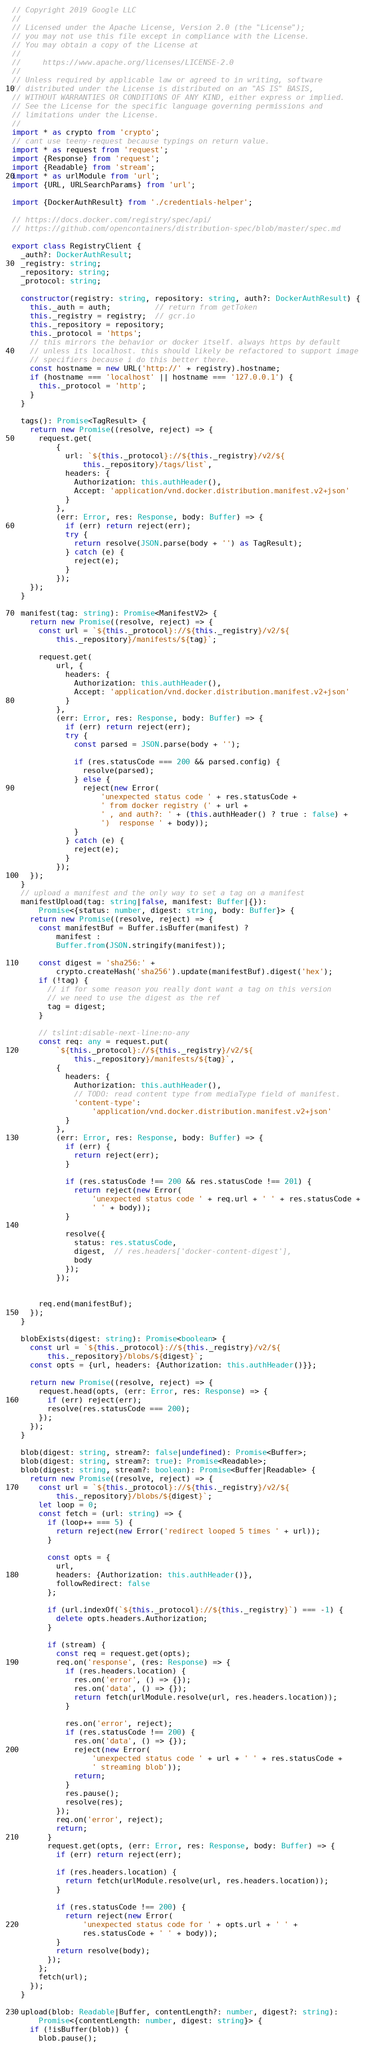Convert code to text. <code><loc_0><loc_0><loc_500><loc_500><_TypeScript_>// Copyright 2019 Google LLC
//
// Licensed under the Apache License, Version 2.0 (the "License");
// you may not use this file except in compliance with the License.
// You may obtain a copy of the License at
//
//     https://www.apache.org/licenses/LICENSE-2.0
//
// Unless required by applicable law or agreed to in writing, software
// distributed under the License is distributed on an "AS IS" BASIS,
// WITHOUT WARRANTIES OR CONDITIONS OF ANY KIND, either express or implied.
// See the License for the specific language governing permissions and
// limitations under the License.
//
import * as crypto from 'crypto';
// cant use teeny-request because typings on return value.
import * as request from 'request';
import {Response} from 'request';
import {Readable} from 'stream';
import * as urlModule from 'url';
import {URL, URLSearchParams} from 'url';

import {DockerAuthResult} from './credentials-helper';

// https://docs.docker.com/registry/spec/api/
// https://github.com/opencontainers/distribution-spec/blob/master/spec.md

export class RegistryClient {
  _auth?: DockerAuthResult;
  _registry: string;
  _repository: string;
  _protocol: string;

  constructor(registry: string, repository: string, auth?: DockerAuthResult) {
    this._auth = auth;          // return from getToken
    this._registry = registry;  // gcr.io
    this._repository = repository;
    this._protocol = 'https';
    // this mirrors the behavior or docker itself. always https by default
    // unless its localhost. this should likely be refactored to support image
    // specifiers because i do this better there.
    const hostname = new URL('http://' + registry).hostname;
    if (hostname === 'localhost' || hostname === '127.0.0.1') {
      this._protocol = 'http';
    }
  }

  tags(): Promise<TagResult> {
    return new Promise((resolve, reject) => {
      request.get(
          {
            url: `${this._protocol}://${this._registry}/v2/${
                this._repository}/tags/list`,
            headers: {
              Authorization: this.authHeader(),
              Accept: 'application/vnd.docker.distribution.manifest.v2+json'
            }
          },
          (err: Error, res: Response, body: Buffer) => {
            if (err) return reject(err);
            try {
              return resolve(JSON.parse(body + '') as TagResult);
            } catch (e) {
              reject(e);
            }
          });
    });
  }

  manifest(tag: string): Promise<ManifestV2> {
    return new Promise((resolve, reject) => {
      const url = `${this._protocol}://${this._registry}/v2/${
          this._repository}/manifests/${tag}`;

      request.get(
          url, {
            headers: {
              Authorization: this.authHeader(),
              Accept: 'application/vnd.docker.distribution.manifest.v2+json'
            }
          },
          (err: Error, res: Response, body: Buffer) => {
            if (err) return reject(err);
            try {
              const parsed = JSON.parse(body + '');

              if (res.statusCode === 200 && parsed.config) {
                resolve(parsed);
              } else {
                reject(new Error(
                    'unexpected status code ' + res.statusCode +
                    ' from docker registry (' + url +
                    ' , and auth?: ' + (this.authHeader() ? true : false) +
                    ')  response ' + body));
              }
            } catch (e) {
              reject(e);
            }
          });
    });
  }
  // upload a manifest and the only way to set a tag on a manifest
  manifestUpload(tag: string|false, manifest: Buffer|{}):
      Promise<{status: number, digest: string, body: Buffer}> {
    return new Promise((resolve, reject) => {
      const manifestBuf = Buffer.isBuffer(manifest) ?
          manifest :
          Buffer.from(JSON.stringify(manifest));

      const digest = 'sha256:' +
          crypto.createHash('sha256').update(manifestBuf).digest('hex');
      if (!tag) {
        // if for some reason you really dont want a tag on this version
        // we need to use the digest as the ref
        tag = digest;
      }

      // tslint:disable-next-line:no-any
      const req: any = request.put(
          `${this._protocol}://${this._registry}/v2/${
              this._repository}/manifests/${tag}`,
          {
            headers: {
              Authorization: this.authHeader(),
              // TODO: read content type from mediaType field of manifest.
              'content-type':
                  'application/vnd.docker.distribution.manifest.v2+json'
            }
          },
          (err: Error, res: Response, body: Buffer) => {
            if (err) {
              return reject(err);
            }

            if (res.statusCode !== 200 && res.statusCode !== 201) {
              return reject(new Error(
                  'unexpected status code ' + req.url + ' ' + res.statusCode +
                  ' ' + body));
            }

            resolve({
              status: res.statusCode,
              digest,  // res.headers['docker-content-digest'],
              body
            });
          });


      req.end(manifestBuf);
    });
  }

  blobExists(digest: string): Promise<boolean> {
    const url = `${this._protocol}://${this._registry}/v2/${
        this._repository}/blobs/${digest}`;
    const opts = {url, headers: {Authorization: this.authHeader()}};

    return new Promise((resolve, reject) => {
      request.head(opts, (err: Error, res: Response) => {
        if (err) reject(err);
        resolve(res.statusCode === 200);
      });
    });
  }

  blob(digest: string, stream?: false|undefined): Promise<Buffer>;
  blob(digest: string, stream?: true): Promise<Readable>;
  blob(digest: string, stream?: boolean): Promise<Buffer|Readable> {
    return new Promise((resolve, reject) => {
      const url = `${this._protocol}://${this._registry}/v2/${
          this._repository}/blobs/${digest}`;
      let loop = 0;
      const fetch = (url: string) => {
        if (loop++ === 5) {
          return reject(new Error('redirect looped 5 times ' + url));
        }

        const opts = {
          url,
          headers: {Authorization: this.authHeader()},
          followRedirect: false
        };

        if (url.indexOf(`${this._protocol}://${this._registry}`) === -1) {
          delete opts.headers.Authorization;
        }

        if (stream) {
          const req = request.get(opts);
          req.on('response', (res: Response) => {
            if (res.headers.location) {
              res.on('error', () => {});
              res.on('data', () => {});
              return fetch(urlModule.resolve(url, res.headers.location));
            }

            res.on('error', reject);
            if (res.statusCode !== 200) {
              res.on('data', () => {});
              reject(new Error(
                  'unexpected status code ' + url + ' ' + res.statusCode +
                  ' streaming blob'));
              return;
            }
            res.pause();
            resolve(res);
          });
          req.on('error', reject);
          return;
        }
        request.get(opts, (err: Error, res: Response, body: Buffer) => {
          if (err) return reject(err);

          if (res.headers.location) {
            return fetch(urlModule.resolve(url, res.headers.location));
          }

          if (res.statusCode !== 200) {
            return reject(new Error(
                'unexpected status code for ' + opts.url + ' ' +
                res.statusCode + ' ' + body));
          }
          return resolve(body);
        });
      };
      fetch(url);
    });
  }

  upload(blob: Readable|Buffer, contentLength?: number, digest?: string):
      Promise<{contentLength: number, digest: string}> {
    if (!isBuffer(blob)) {
      blob.pause();</code> 